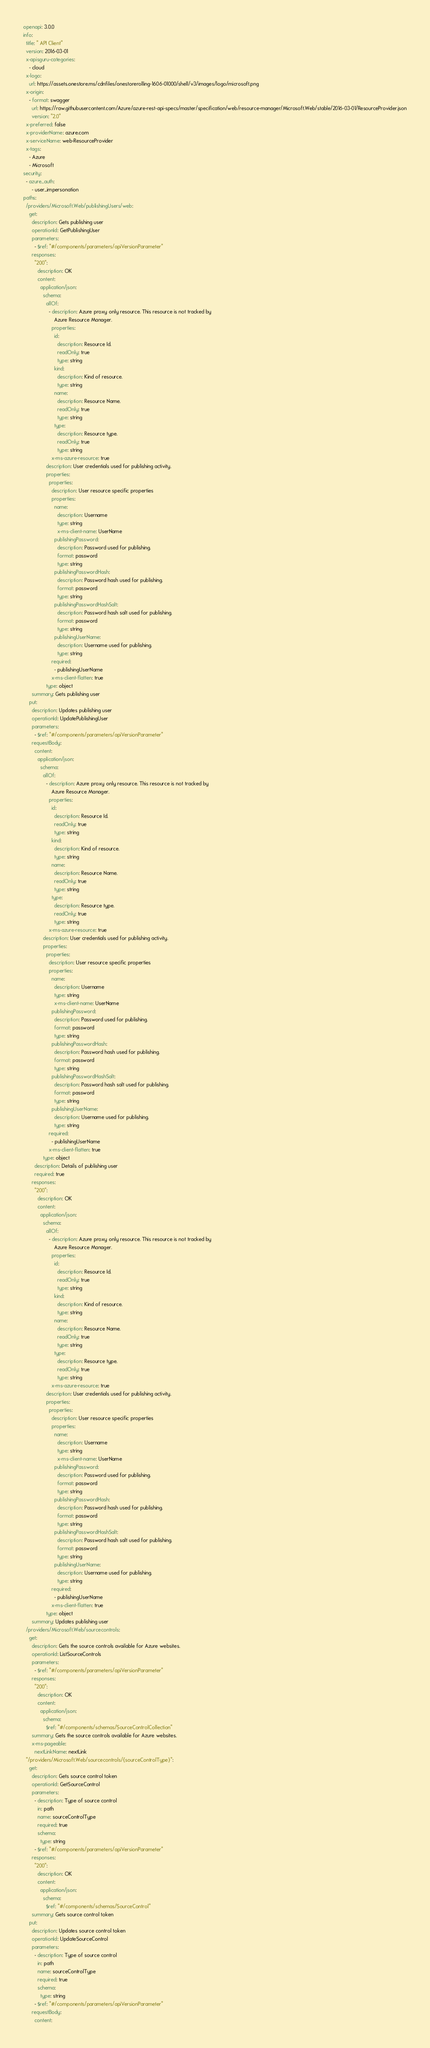Convert code to text. <code><loc_0><loc_0><loc_500><loc_500><_YAML_>openapi: 3.0.0
info:
  title: " API Client"
  version: 2016-03-01
  x-apisguru-categories:
    - cloud
  x-logo:
    url: https://assets.onestore.ms/cdnfiles/onestorerolling-1606-01000/shell/v3/images/logo/microsoft.png
  x-origin:
    - format: swagger
      url: https://raw.githubusercontent.com/Azure/azure-rest-api-specs/master/specification/web/resource-manager/Microsoft.Web/stable/2016-03-01/ResourceProvider.json
      version: "2.0"
  x-preferred: false
  x-providerName: azure.com
  x-serviceName: web-ResourceProvider
  x-tags:
    - Azure
    - Microsoft
security:
  - azure_auth:
      - user_impersonation
paths:
  /providers/Microsoft.Web/publishingUsers/web:
    get:
      description: Gets publishing user
      operationId: GetPublishingUser
      parameters:
        - $ref: "#/components/parameters/apiVersionParameter"
      responses:
        "200":
          description: OK
          content:
            application/json:
              schema:
                allOf:
                  - description: Azure proxy only resource. This resource is not tracked by
                      Azure Resource Manager.
                    properties:
                      id:
                        description: Resource Id.
                        readOnly: true
                        type: string
                      kind:
                        description: Kind of resource.
                        type: string
                      name:
                        description: Resource Name.
                        readOnly: true
                        type: string
                      type:
                        description: Resource type.
                        readOnly: true
                        type: string
                    x-ms-azure-resource: true
                description: User credentials used for publishing activity.
                properties:
                  properties:
                    description: User resource specific properties
                    properties:
                      name:
                        description: Username
                        type: string
                        x-ms-client-name: UserName
                      publishingPassword:
                        description: Password used for publishing.
                        format: password
                        type: string
                      publishingPasswordHash:
                        description: Password hash used for publishing.
                        format: password
                        type: string
                      publishingPasswordHashSalt:
                        description: Password hash salt used for publishing.
                        format: password
                        type: string
                      publishingUserName:
                        description: Username used for publishing.
                        type: string
                    required:
                      - publishingUserName
                    x-ms-client-flatten: true
                type: object
      summary: Gets publishing user
    put:
      description: Updates publishing user
      operationId: UpdatePublishingUser
      parameters:
        - $ref: "#/components/parameters/apiVersionParameter"
      requestBody:
        content:
          application/json:
            schema:
              allOf:
                - description: Azure proxy only resource. This resource is not tracked by
                    Azure Resource Manager.
                  properties:
                    id:
                      description: Resource Id.
                      readOnly: true
                      type: string
                    kind:
                      description: Kind of resource.
                      type: string
                    name:
                      description: Resource Name.
                      readOnly: true
                      type: string
                    type:
                      description: Resource type.
                      readOnly: true
                      type: string
                  x-ms-azure-resource: true
              description: User credentials used for publishing activity.
              properties:
                properties:
                  description: User resource specific properties
                  properties:
                    name:
                      description: Username
                      type: string
                      x-ms-client-name: UserName
                    publishingPassword:
                      description: Password used for publishing.
                      format: password
                      type: string
                    publishingPasswordHash:
                      description: Password hash used for publishing.
                      format: password
                      type: string
                    publishingPasswordHashSalt:
                      description: Password hash salt used for publishing.
                      format: password
                      type: string
                    publishingUserName:
                      description: Username used for publishing.
                      type: string
                  required:
                    - publishingUserName
                  x-ms-client-flatten: true
              type: object
        description: Details of publishing user
        required: true
      responses:
        "200":
          description: OK
          content:
            application/json:
              schema:
                allOf:
                  - description: Azure proxy only resource. This resource is not tracked by
                      Azure Resource Manager.
                    properties:
                      id:
                        description: Resource Id.
                        readOnly: true
                        type: string
                      kind:
                        description: Kind of resource.
                        type: string
                      name:
                        description: Resource Name.
                        readOnly: true
                        type: string
                      type:
                        description: Resource type.
                        readOnly: true
                        type: string
                    x-ms-azure-resource: true
                description: User credentials used for publishing activity.
                properties:
                  properties:
                    description: User resource specific properties
                    properties:
                      name:
                        description: Username
                        type: string
                        x-ms-client-name: UserName
                      publishingPassword:
                        description: Password used for publishing.
                        format: password
                        type: string
                      publishingPasswordHash:
                        description: Password hash used for publishing.
                        format: password
                        type: string
                      publishingPasswordHashSalt:
                        description: Password hash salt used for publishing.
                        format: password
                        type: string
                      publishingUserName:
                        description: Username used for publishing.
                        type: string
                    required:
                      - publishingUserName
                    x-ms-client-flatten: true
                type: object
      summary: Updates publishing user
  /providers/Microsoft.Web/sourcecontrols:
    get:
      description: Gets the source controls available for Azure websites.
      operationId: ListSourceControls
      parameters:
        - $ref: "#/components/parameters/apiVersionParameter"
      responses:
        "200":
          description: OK
          content:
            application/json:
              schema:
                $ref: "#/components/schemas/SourceControlCollection"
      summary: Gets the source controls available for Azure websites.
      x-ms-pageable:
        nextLinkName: nextLink
  "/providers/Microsoft.Web/sourcecontrols/{sourceControlType}":
    get:
      description: Gets source control token
      operationId: GetSourceControl
      parameters:
        - description: Type of source control
          in: path
          name: sourceControlType
          required: true
          schema:
            type: string
        - $ref: "#/components/parameters/apiVersionParameter"
      responses:
        "200":
          description: OK
          content:
            application/json:
              schema:
                $ref: "#/components/schemas/SourceControl"
      summary: Gets source control token
    put:
      description: Updates source control token
      operationId: UpdateSourceControl
      parameters:
        - description: Type of source control
          in: path
          name: sourceControlType
          required: true
          schema:
            type: string
        - $ref: "#/components/parameters/apiVersionParameter"
      requestBody:
        content:</code> 